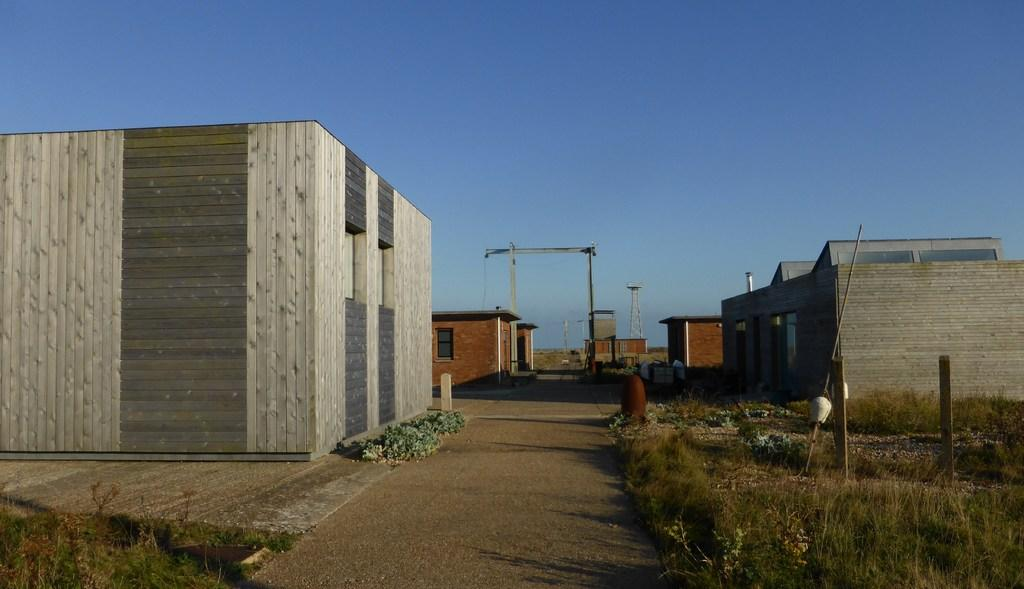What type of structures can be seen in the image? There are buildings with windows in the image. What type of vegetation is present in the image? There is grass in the image. What type of surface can be seen in the image? There is a path in the image. What is visible in the background of the image? The sky is visible in the background of the image. Where is the library located in the image? There is no library present in the image. How does the grass provide comfort in the image? The grass does not provide comfort in the image; it is simply a visual element. 